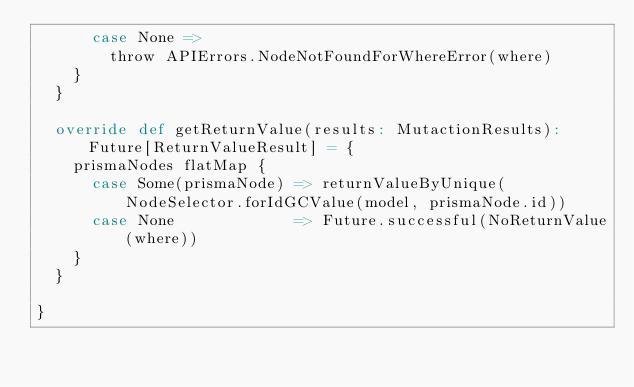Convert code to text. <code><loc_0><loc_0><loc_500><loc_500><_Scala_>      case None =>
        throw APIErrors.NodeNotFoundForWhereError(where)
    }
  }

  override def getReturnValue(results: MutactionResults): Future[ReturnValueResult] = {
    prismaNodes flatMap {
      case Some(prismaNode) => returnValueByUnique(NodeSelector.forIdGCValue(model, prismaNode.id))
      case None             => Future.successful(NoReturnValue(where))
    }
  }

}
</code> 